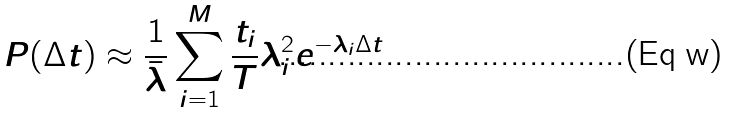Convert formula to latex. <formula><loc_0><loc_0><loc_500><loc_500>P ( \Delta t ) \approx \frac { 1 } { \bar { \lambda } } \sum _ { i = 1 } ^ { M } \frac { t _ { i } } { T } \lambda _ { i } ^ { 2 } e ^ { - \lambda _ { i } \Delta t }</formula> 